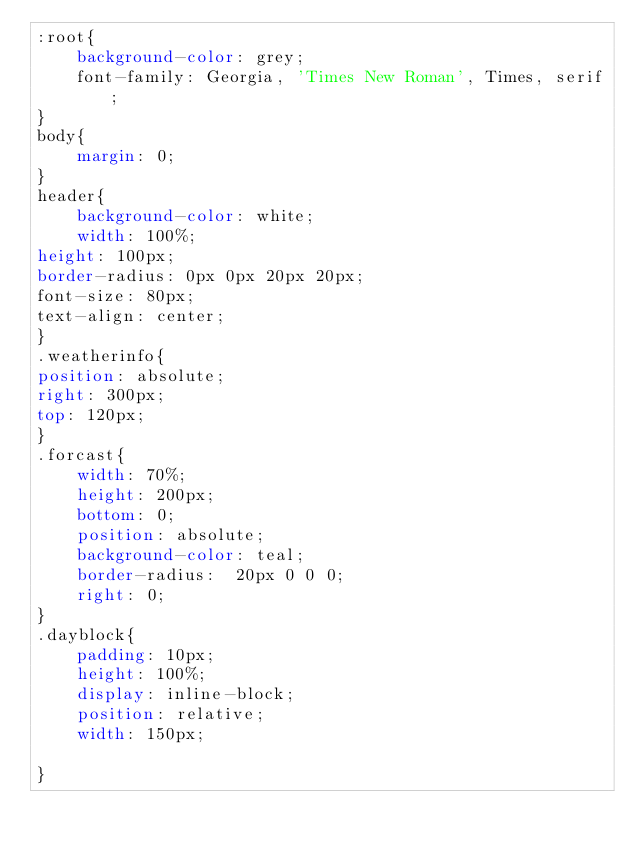Convert code to text. <code><loc_0><loc_0><loc_500><loc_500><_CSS_>:root{
    background-color: grey;
    font-family: Georgia, 'Times New Roman', Times, serif;
}
body{
    margin: 0;
}
header{
    background-color: white;
    width: 100%;
height: 100px;
border-radius: 0px 0px 20px 20px;
font-size: 80px;
text-align: center;
}
.weatherinfo{
position: absolute;
right: 300px;
top: 120px;
}
.forcast{
    width: 70%;
    height: 200px;
    bottom: 0;
    position: absolute;
    background-color: teal;
    border-radius:  20px 0 0 0;
    right: 0;
}
.dayblock{
    padding: 10px;
    height: 100%;
    display: inline-block;
    position: relative;
    width: 150px;
    
}</code> 